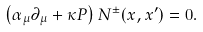Convert formula to latex. <formula><loc_0><loc_0><loc_500><loc_500>\left ( \alpha _ { \mu } \partial _ { \mu } + \kappa P \right ) N ^ { \pm } ( x , x ^ { \prime } ) = 0 .</formula> 